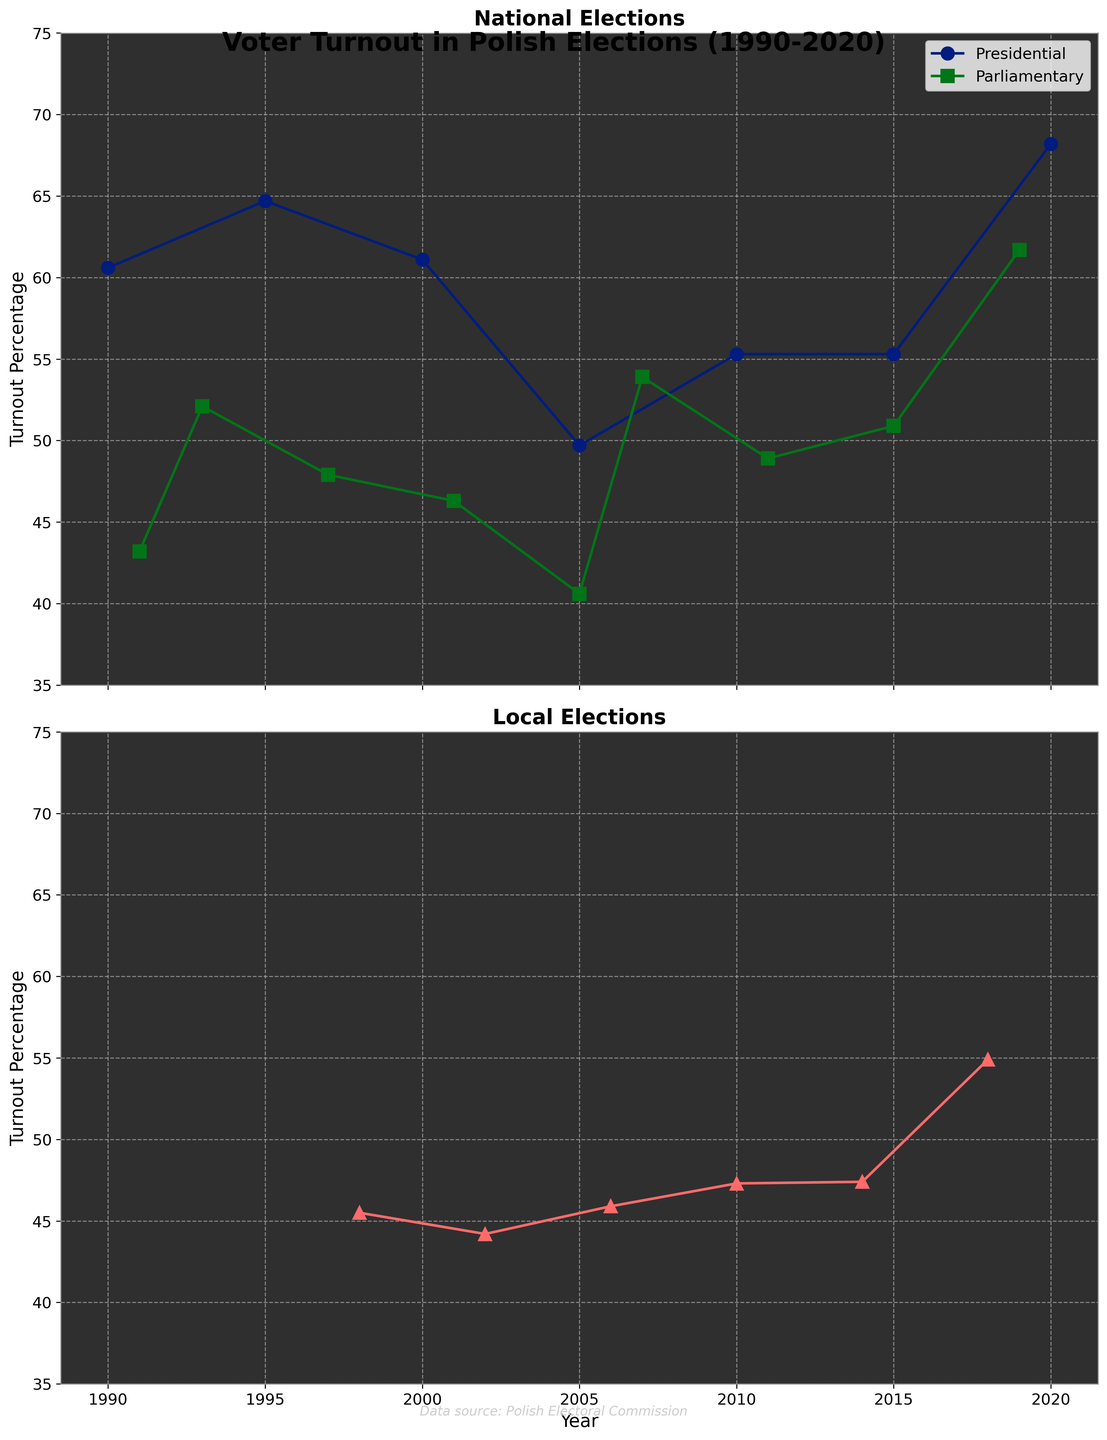What is the title of the plot? The title of the plot is written at the top. It reads "Voter Turnout in Polish Elections (1990-2020)."
Answer: Voter Turnout in Polish Elections (1990-2020) What are the Y-axis labels of the plots? To determine the Y-axis labels, we look at the text beside the vertical axis on both subplots. The label for both is "Turnout Percentage."
Answer: Turnout Percentage Which election type has the highest turnout percentage in the plot? We look at all the points and compare the turnout percentages. The highest is for the 2020 Presidential election with 68.2%.
Answer: Presidential election in 2020 How did the turnout percentage for local elections change from 2014 to 2018? We compare the turnout percentages for local elections in 2014 and 2018. In 2014, it was 47.4%, and in 2018 it increased to 54.9%.
Answer: Increased by 7.5% What is the average turnout percentage for parliamentary elections based on the plot? To find the average, add the turnout percentages for parliamentary elections and divide by the number of points. (43.2 + 52.1 + 47.9 + 46.3 + 40.6 + 53.9 + 48.9 + 50.9 + 61.7)/9 = 49.5%
Answer: 49.5% Which year had the lowest voter turnout for presidential elections? Check the points for presidential elections and find the smallest value. In 2005, the turnout was 49.7%, the lowest among presidential elections.
Answer: 2005 How does the voter turnout trend for local elections from 1998 to 2018 appear? Examine the plotted points for local elections from 1998 to 2018. The trend line shows a general increase from around 45.5% to 54.9% over these years.
Answer: Increasing trend Are there more points plotted for national or local elections? Count the number of points for both subplots. National elections (Presidential + Parliamentary) have 14 points, Local elections have 6 points.
Answer: National elections have more points When was the first election type displayed in the plot? The first year represented in the data is the year on the far left of the plots, which is 1990 for presidential elections.
Answer: 1990 Which had a higher turnout percentage in 2005, presidential or parliamentary elections? Compare the 2005 data points for both election types. Presidential turnout was 49.7% and parliamentary was 40.6%; thus, presidential was higher.
Answer: Presidential 